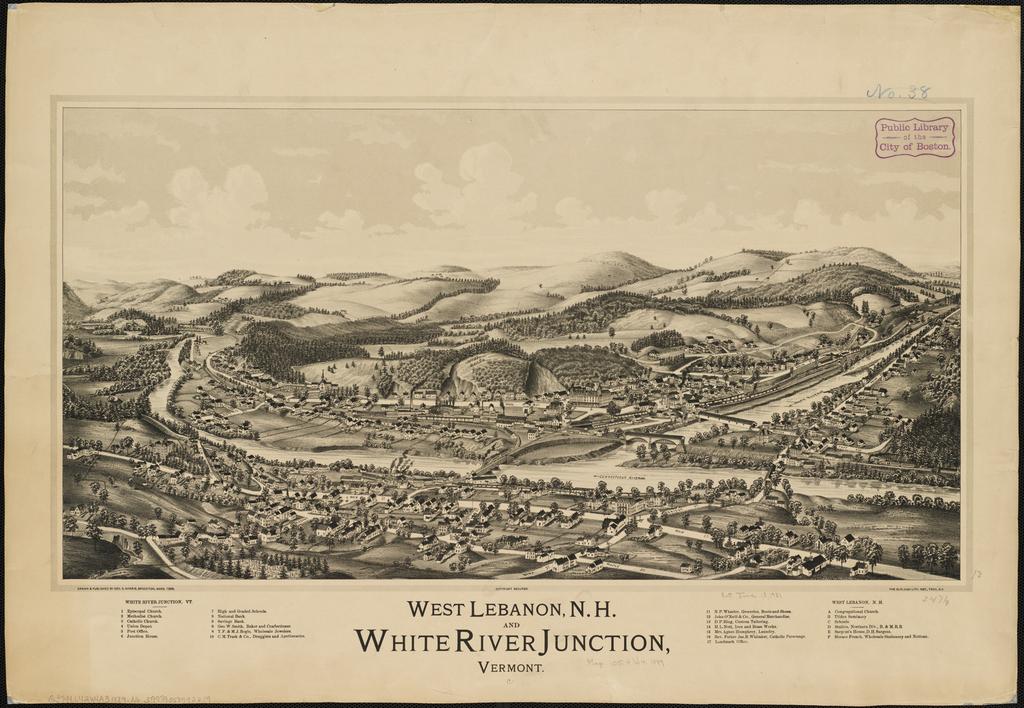What is the drawing portraying?
Offer a very short reply. White river junction. What state is this from?
Provide a succinct answer. Vermont. 